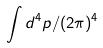<formula> <loc_0><loc_0><loc_500><loc_500>\int d ^ { 4 } p / ( 2 \pi ) ^ { 4 }</formula> 